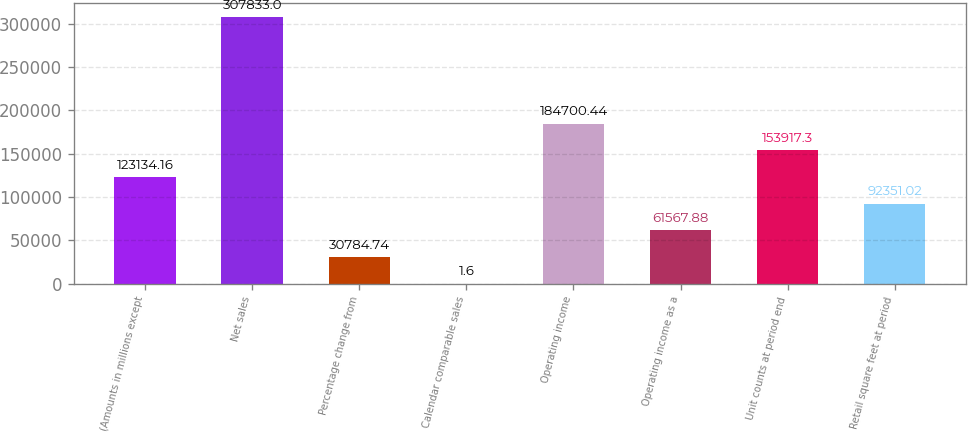Convert chart to OTSL. <chart><loc_0><loc_0><loc_500><loc_500><bar_chart><fcel>(Amounts in millions except<fcel>Net sales<fcel>Percentage change from<fcel>Calendar comparable sales<fcel>Operating income<fcel>Operating income as a<fcel>Unit counts at period end<fcel>Retail square feet at period<nl><fcel>123134<fcel>307833<fcel>30784.7<fcel>1.6<fcel>184700<fcel>61567.9<fcel>153917<fcel>92351<nl></chart> 